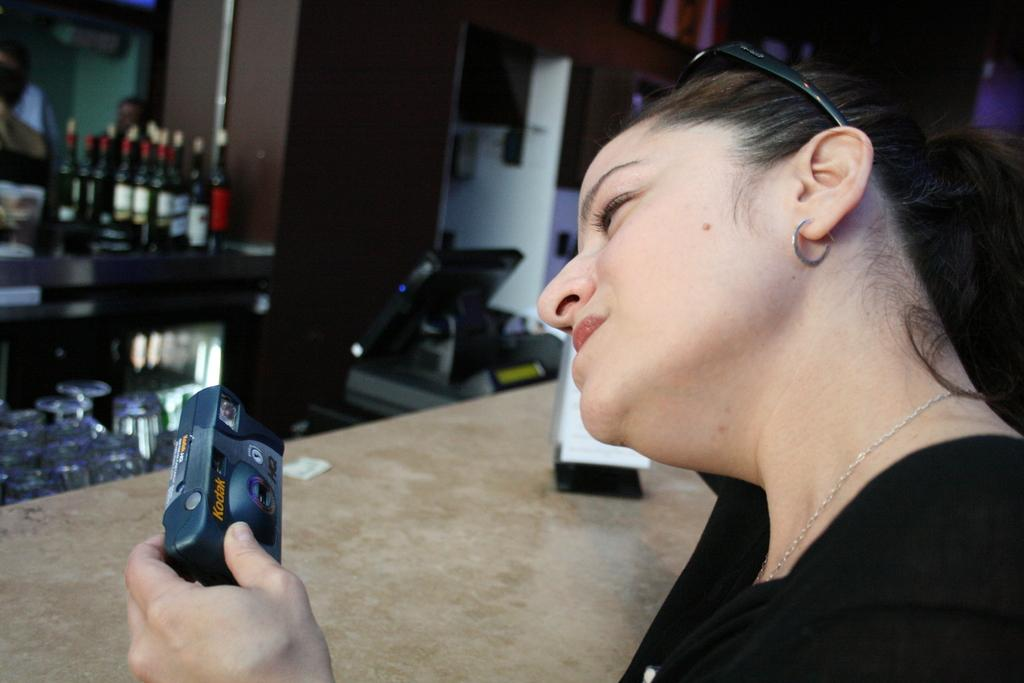What is the person in the image doing? The person in the image is holding a camera. What is the person wearing in the image? The person is wearing a black dress. What can be seen on the table in the background of the image? There are bottles on a table in the background. What type of furniture is visible in the background of the image? There are brown-colored cupboards in the background. What type of flower is being used as a prop in the image? There is no flower present in the image. 